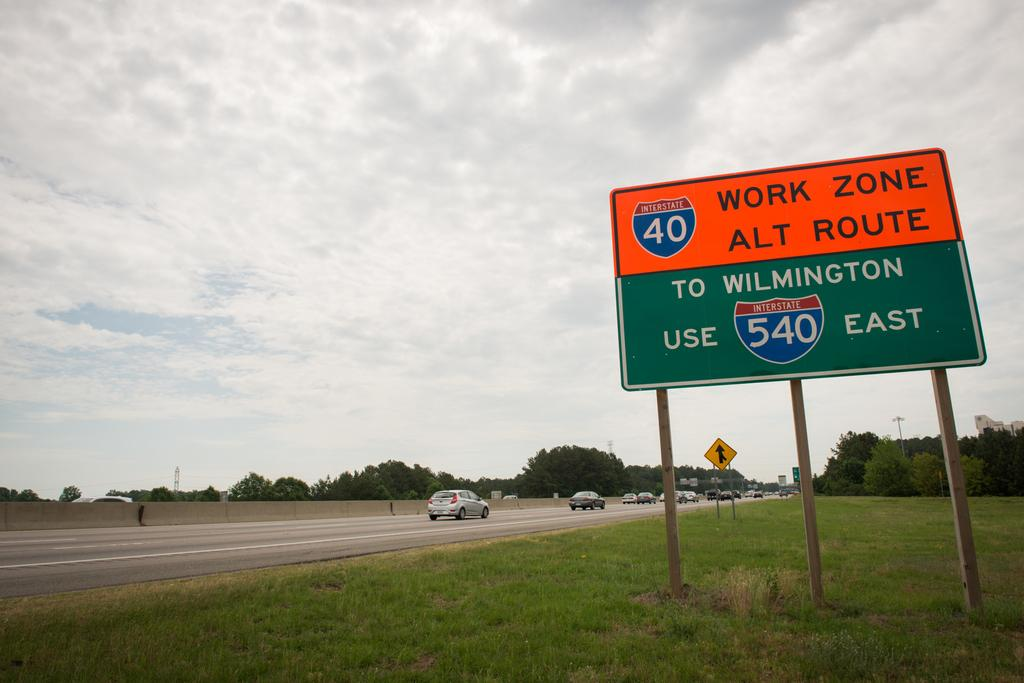<image>
Present a compact description of the photo's key features. A sign showing an alternate route through a work zone on Interstate 40. 